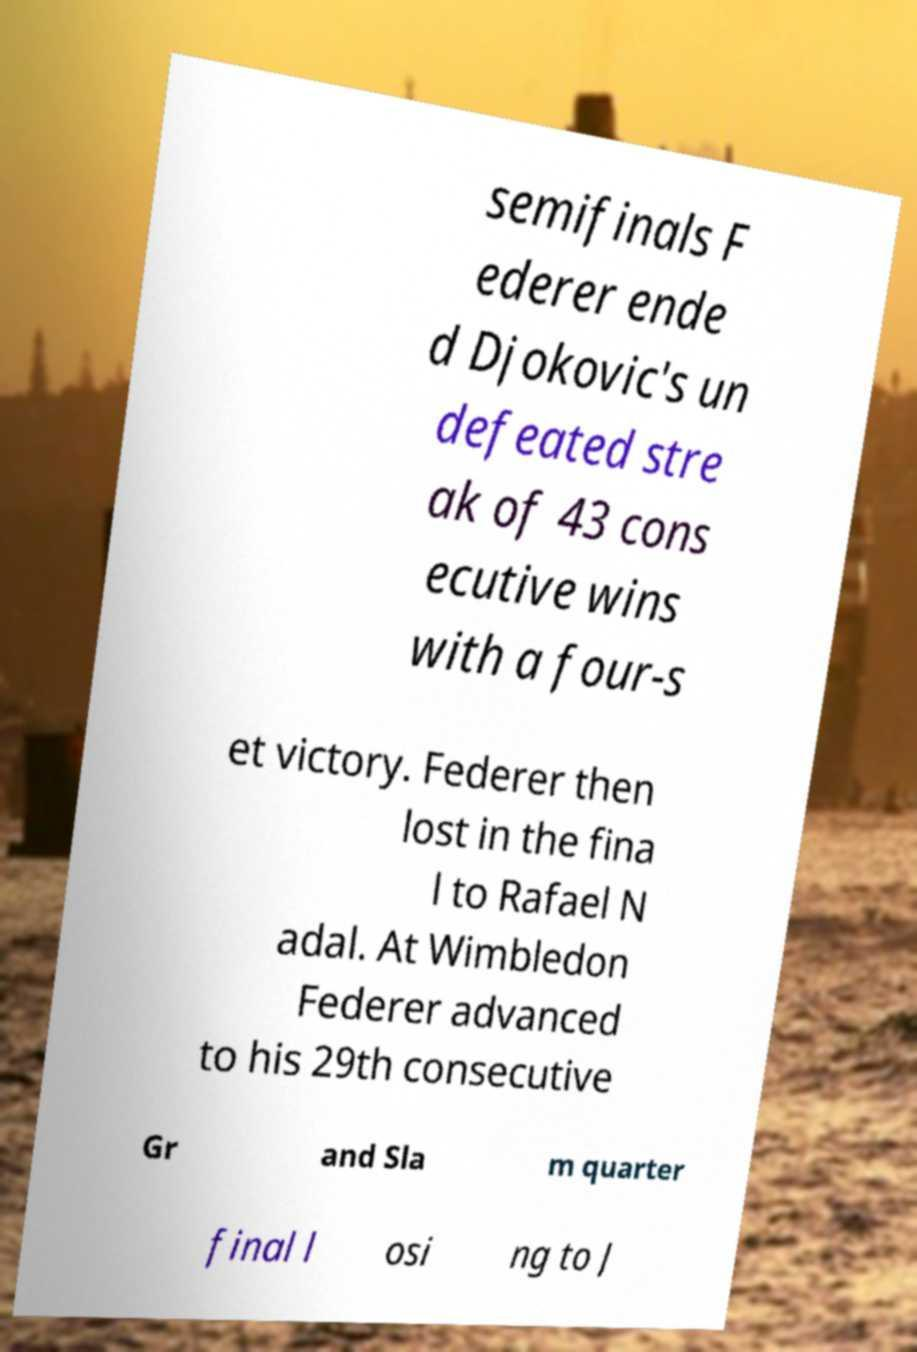Could you assist in decoding the text presented in this image and type it out clearly? semifinals F ederer ende d Djokovic's un defeated stre ak of 43 cons ecutive wins with a four-s et victory. Federer then lost in the fina l to Rafael N adal. At Wimbledon Federer advanced to his 29th consecutive Gr and Sla m quarter final l osi ng to J 